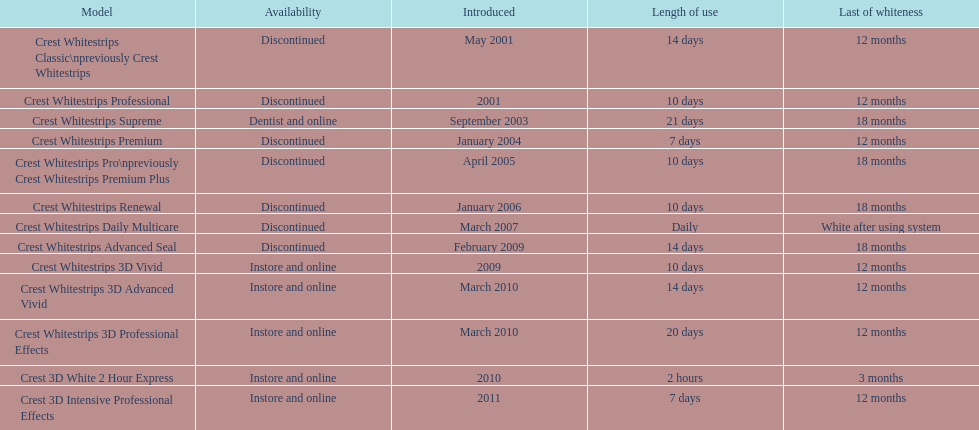Parse the table in full. {'header': ['Model', 'Availability', 'Introduced', 'Length of use', 'Last of whiteness'], 'rows': [['Crest Whitestrips Classic\\npreviously Crest Whitestrips', 'Discontinued', 'May 2001', '14 days', '12 months'], ['Crest Whitestrips Professional', 'Discontinued', '2001', '10 days', '12 months'], ['Crest Whitestrips Supreme', 'Dentist and online', 'September 2003', '21 days', '18 months'], ['Crest Whitestrips Premium', 'Discontinued', 'January 2004', '7 days', '12 months'], ['Crest Whitestrips Pro\\npreviously Crest Whitestrips Premium Plus', 'Discontinued', 'April 2005', '10 days', '18 months'], ['Crest Whitestrips Renewal', 'Discontinued', 'January 2006', '10 days', '18 months'], ['Crest Whitestrips Daily Multicare', 'Discontinued', 'March 2007', 'Daily', 'White after using system'], ['Crest Whitestrips Advanced Seal', 'Discontinued', 'February 2009', '14 days', '18 months'], ['Crest Whitestrips 3D Vivid', 'Instore and online', '2009', '10 days', '12 months'], ['Crest Whitestrips 3D Advanced Vivid', 'Instore and online', 'March 2010', '14 days', '12 months'], ['Crest Whitestrips 3D Professional Effects', 'Instore and online', 'March 2010', '20 days', '12 months'], ['Crest 3D White 2 Hour Express', 'Instore and online', '2010', '2 hours', '3 months'], ['Crest 3D Intensive Professional Effects', 'Instore and online', '2011', '7 days', '12 months']]} Which product had a longer usage duration, crest whitestrips classic or crest whitestrips 3d vivid? Crest Whitestrips Classic. 